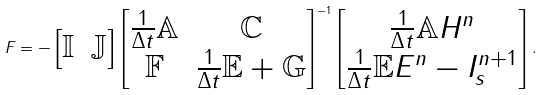<formula> <loc_0><loc_0><loc_500><loc_500>F = - \begin{bmatrix} \mathbb { I } & \mathbb { J } \end{bmatrix} \begin{bmatrix} \frac { 1 } { \Delta t } \mathbb { A } & \mathbb { C } \\ \mathbb { F } & \frac { 1 } { \Delta t } \mathbb { E } + \mathbb { G } \end{bmatrix} ^ { - 1 } \begin{bmatrix} \frac { 1 } { \Delta t } \mathbb { A } H ^ { n } \\ \frac { 1 } { \Delta t } \mathbb { E } E ^ { n } - I _ { s } ^ { n + 1 } \end{bmatrix} .</formula> 